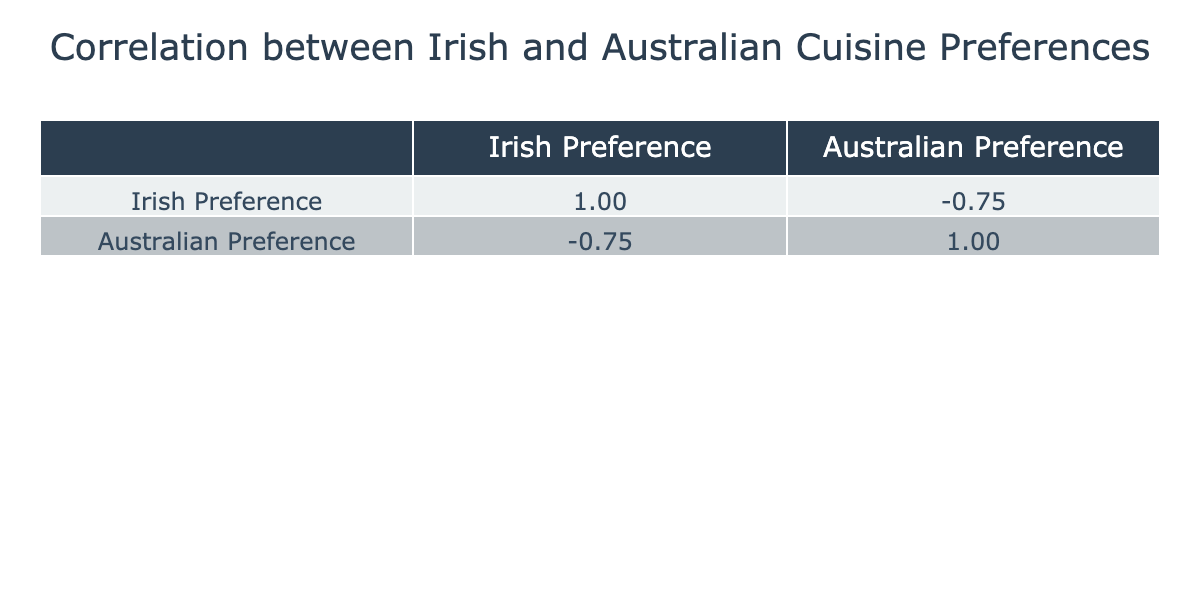What is the Irish Preference Score for Irish Stew? The table indicates a score of 8 for Irish Stew in the Irish Preference column.
Answer: 8 What is the Australian Preference Score for Fish and Chips? The table indicates a score of 9 for Fish and Chips in the Australian Preference column.
Answer: 9 Are there any food items with the same preference score in both Irish and Australian cuisines? By examining the scores, no food items share the same preference score in both columns.
Answer: No Which food item has the highest Irish Preference Score, and what is that score? The food item with the highest Irish Preference Score is Soda Bread with a score of 9.
Answer: Soda Bread, 9 What is the difference in preference scores for Vegemite on Toast between Australian and Irish preferences? Vegemite on Toast has a score of 10 in Australian preferences and a score of 2 in Irish preferences, resulting in a difference of 10 - 2 = 8.
Answer: 8 How many food items have a higher Australian Preference Score than Irish Preference Score? The food items with higher Australian scores than Irish scores are Fish and Chips, Vegemite on Toast, Barramundi, Meat Pie, Pavlova, Damper, and Anzac Biscuits, totaling 7 items.
Answer: 7 What is the average Irish Preference Score for all food items listed? To calculate the average, sum all the Irish scores (8 + 6 + 7 + 2 + 7 + 4 + 9 + 3 + 8 + 2 + 6 = 63) and divide by the number of items (12): 63 / 12 = 5.25.
Answer: 5.25 Which food item has the lowest Irish Preference Score, and what is that score? The food item with the lowest Irish Preference Score is Vegemite on Toast with a score of 2.
Answer: Vegemite on Toast, 2 Is there a food item where the Irish Preference Score is greater than the Australian Preference Score? Yes, several items like Irish Stew, Bangers and Mash, and Shepherd's Pie have higher Irish scores than Australian scores.
Answer: Yes 